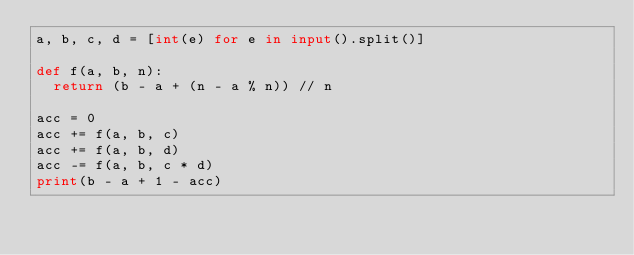Convert code to text. <code><loc_0><loc_0><loc_500><loc_500><_Python_>a, b, c, d = [int(e) for e in input().split()]

def f(a, b, n):
  return (b - a + (n - a % n)) // n 

acc = 0
acc += f(a, b, c)
acc += f(a, b, d)
acc -= f(a, b, c * d)
print(b - a + 1 - acc)
</code> 